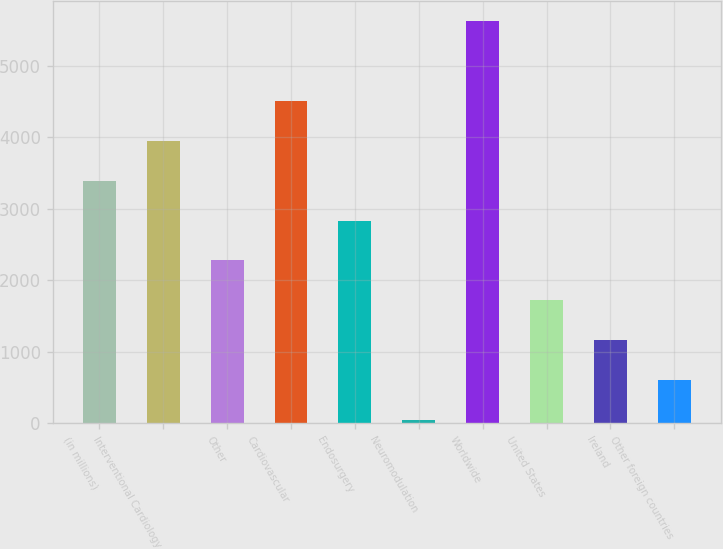Convert chart to OTSL. <chart><loc_0><loc_0><loc_500><loc_500><bar_chart><fcel>(in millions)<fcel>Interventional Cardiology<fcel>Other<fcel>Cardiovascular<fcel>Endosurgery<fcel>Neuromodulation<fcel>Worldwide<fcel>United States<fcel>Ireland<fcel>Other foreign countries<nl><fcel>3392.8<fcel>3950.6<fcel>2277.2<fcel>4508.4<fcel>2835<fcel>46<fcel>5624<fcel>1719.4<fcel>1161.6<fcel>603.8<nl></chart> 